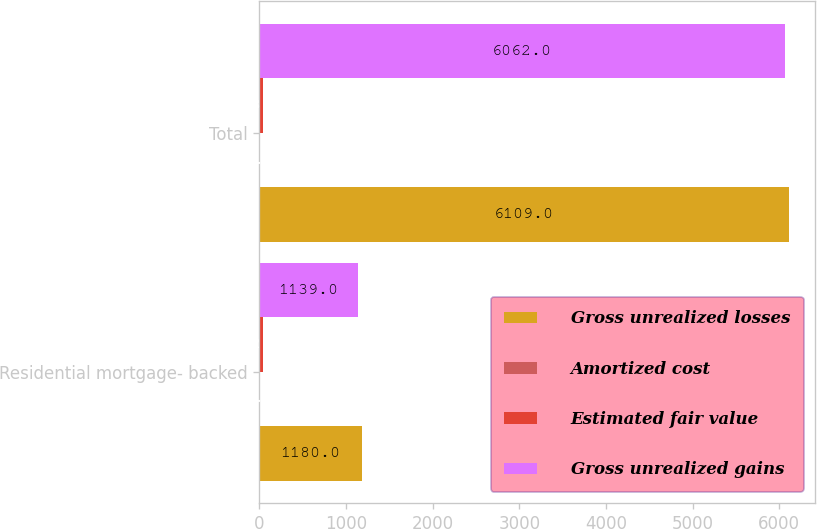Convert chart. <chart><loc_0><loc_0><loc_500><loc_500><stacked_bar_chart><ecel><fcel>Residential mortgage- backed<fcel>Total<nl><fcel>Gross unrealized losses<fcel>1180<fcel>6109<nl><fcel>Amortized cost<fcel>1<fcel>1<nl><fcel>Estimated fair value<fcel>42<fcel>48<nl><fcel>Gross unrealized gains<fcel>1139<fcel>6062<nl></chart> 